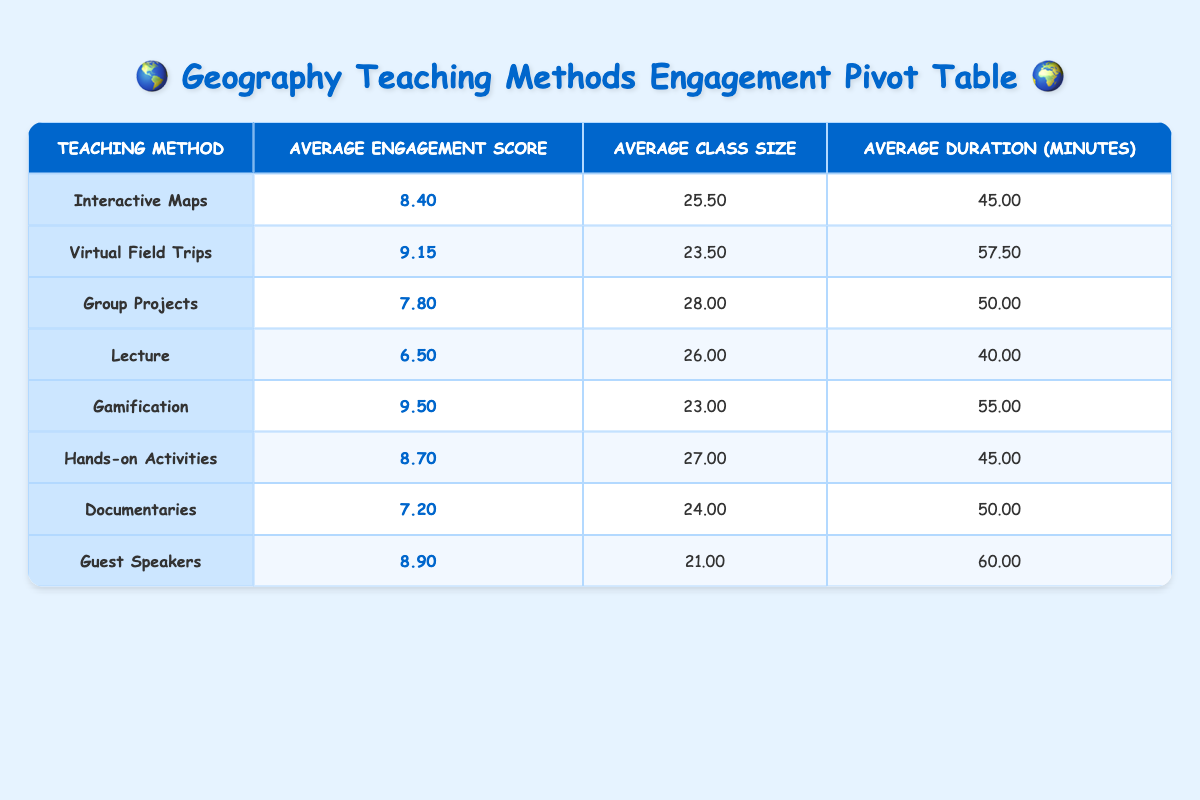What is the average engagement score for the teaching method "Interactive Maps"? The engagement score for "Interactive Maps" is listed in the table as 8.40. This value represents the average engagement score for this teaching method across different classes.
Answer: 8.40 Which teaching method has the highest average engagement score? Checking the "Average Engagement Score" column, "Gamification" has the highest score at 9.50. Therefore, it is the method with the highest average engagement score.
Answer: Gamification Is the average class size for "Virtual Field Trips" greater than or equal to 24? The average class size for "Virtual Field Trips" is 23.50. Since 23.50 is less than 24, the statement is false.
Answer: No How much longer is the average duration of "Guest Speakers" compared to "Lecture"? The average duration for "Guest Speakers" is 60.00 minutes, while for "Lecture," it is 40.00 minutes. The difference is 60.00 - 40.00 = 20.00 minutes, indicating that "Guest Speakers" lasts 20 minutes longer.
Answer: 20.00 What is the average engagement score for all methods? To find the average engagement score, add all the engagement scores (8.40, 9.15, 7.80, 6.50, 9.50, 8.70, 7.20, 8.90) which equals 67.15, then divide by 8 (the number of methods): 67.15 / 8 = 8.39. Therefore, the average engagement score for all methods is 8.39.
Answer: 8.39 Which teaching method is most likely to involve active participation based on the engagement scores provided? Comparing the engagement scores, "Gamification" has the highest score at 9.50, suggesting it likely involves the most active participation among students compared to the other methods.
Answer: Gamification Is there a teaching method that has an engagement score of 8.0 or higher? Yes, several methods exceed an engagement score of 8.0, including "Interactive Maps," "Virtual Field Trips," "Gamification," "Hands-on Activities," and "Guest Speakers." Therefore, the answer is yes.
Answer: Yes 